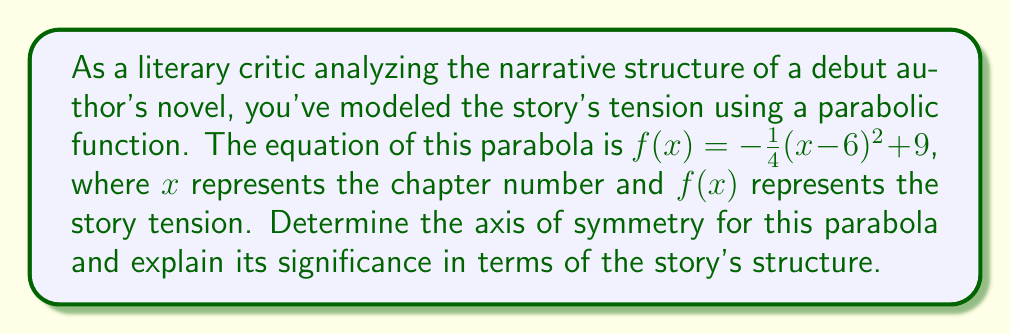Provide a solution to this math problem. To analyze the symmetry of this parabola and its relevance to the story's structure, we'll follow these steps:

1) The general form of a parabola is $f(x) = a(x-h)^2 + k$, where $(h,k)$ is the vertex of the parabola.

2) In our equation $f(x) = -\frac{1}{4}(x-6)^2 + 9$, we can identify:
   $a = -\frac{1}{4}$
   $h = 6$
   $k = 9$

3) The axis of symmetry for a parabola is always a vertical line that passes through the vertex. Its equation is $x = h$.

4) Therefore, the axis of symmetry for this parabola is $x = 6$.

5) In the context of the story's structure:
   - The x-axis represents the chapters of the book.
   - The y-axis represents the level of tension in the story.
   - The parabola opens downward (because $a$ is negative), indicating that tension rises and then falls.
   - The axis of symmetry at $x = 6$ suggests that the story's tension peaks at chapter 6.

6) This symmetric structure implies that:
   - The tension builds up in the first 6 chapters.
   - Chapter 6 is likely the climax of the story.
   - The tension gradually resolves in the last 6 chapters, mirroring the build-up.

This parabolic model provides insight into the author's narrative pacing and structure, showing a balanced approach to tension development and resolution centered around a mid-story climax.
Answer: The axis of symmetry is $x = 6$, indicating that the story's tension peaks at chapter 6, with a symmetric build-up and resolution of tension around this central point. 